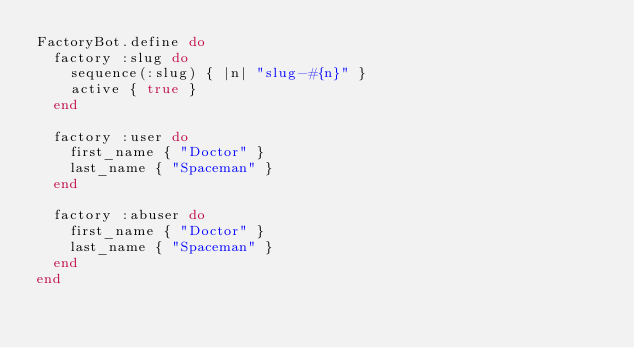<code> <loc_0><loc_0><loc_500><loc_500><_Ruby_>FactoryBot.define do
  factory :slug do
    sequence(:slug) { |n| "slug-#{n}" }
    active { true }
  end

  factory :user do
    first_name { "Doctor" }
    last_name { "Spaceman" }
  end

  factory :abuser do
    first_name { "Doctor" }
    last_name { "Spaceman" }
  end
end
</code> 